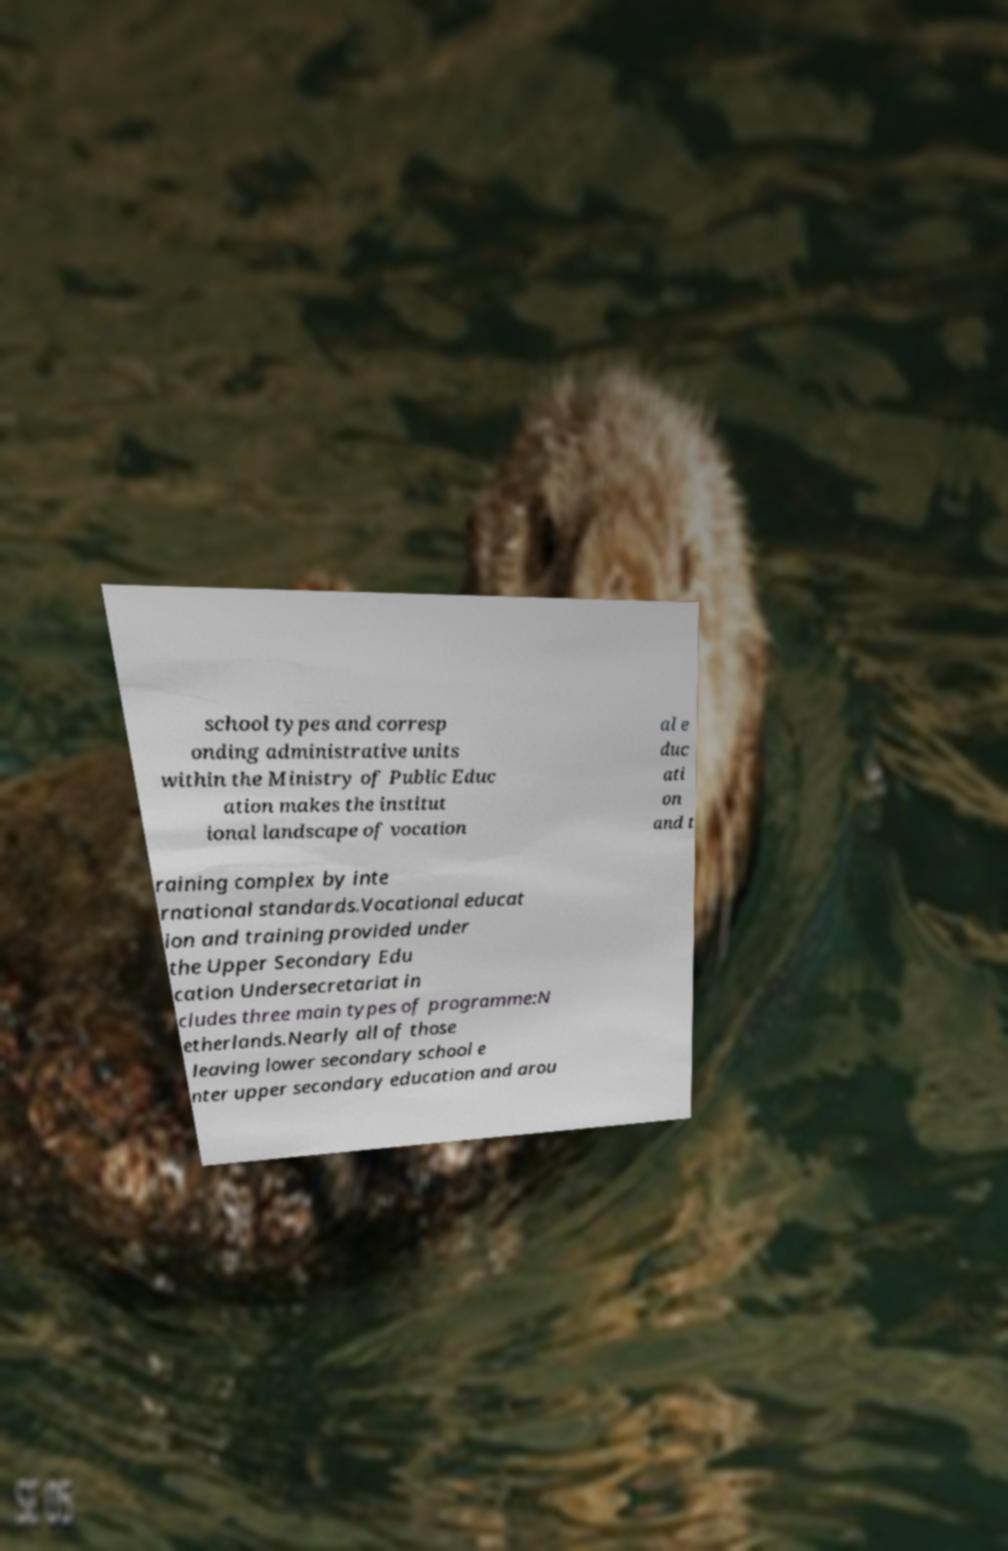Could you extract and type out the text from this image? school types and corresp onding administrative units within the Ministry of Public Educ ation makes the institut ional landscape of vocation al e duc ati on and t raining complex by inte rnational standards.Vocational educat ion and training provided under the Upper Secondary Edu cation Undersecretariat in cludes three main types of programme:N etherlands.Nearly all of those leaving lower secondary school e nter upper secondary education and arou 